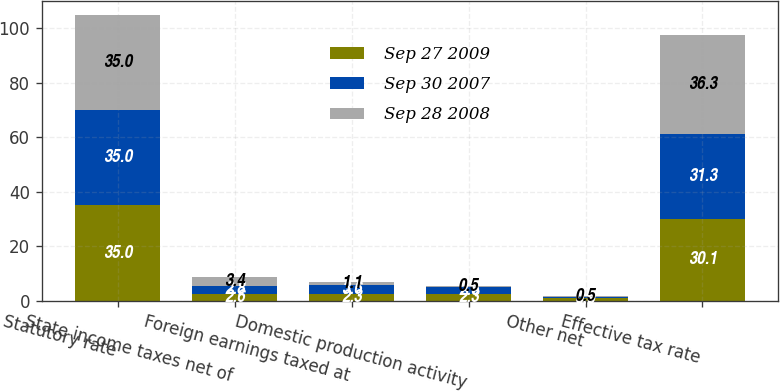<chart> <loc_0><loc_0><loc_500><loc_500><stacked_bar_chart><ecel><fcel>Statutory rate<fcel>State income taxes net of<fcel>Foreign earnings taxed at<fcel>Domestic production activity<fcel>Other net<fcel>Effective tax rate<nl><fcel>Sep 27 2009<fcel>35<fcel>2.6<fcel>2.3<fcel>2.3<fcel>0.9<fcel>30.1<nl><fcel>Sep 30 2007<fcel>35<fcel>2.8<fcel>3.6<fcel>2.6<fcel>0.3<fcel>31.3<nl><fcel>Sep 28 2008<fcel>35<fcel>3.4<fcel>1.1<fcel>0.5<fcel>0.5<fcel>36.3<nl></chart> 